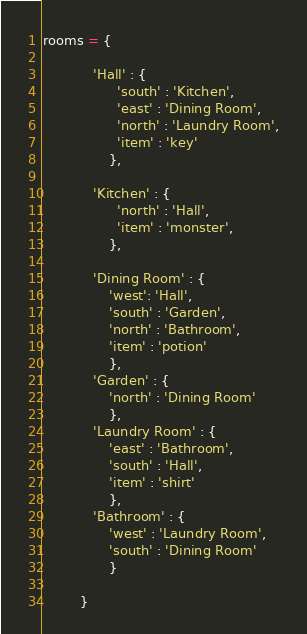<code> <loc_0><loc_0><loc_500><loc_500><_Python_>rooms = {

            'Hall' : {
                  'south' : 'Kitchen',
                  'east' : 'Dining Room',
                  'north' : 'Laundry Room',
                  'item' : 'key'
                },

            'Kitchen' : {
                  'north' : 'Hall',
                  'item' : 'monster',
                },

            'Dining Room' : {
                'west': 'Hall',
                'south' : 'Garden',
                'north' : 'Bathroom',
                'item' : 'potion'
                },
            'Garden' : {
                'north' : 'Dining Room'
                },
            'Laundry Room' : {
                'east' : 'Bathroom',
                'south' : 'Hall',
                'item' : 'shirt'
                },
            'Bathroom' : {
                'west' : 'Laundry Room',
                'south' : 'Dining Room'
                }

         }

</code> 